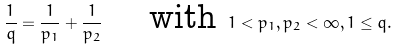Convert formula to latex. <formula><loc_0><loc_0><loc_500><loc_500>\frac { 1 } { q } = \frac { 1 } { p _ { 1 } } + \frac { 1 } { p _ { 2 } } \quad \text { with } 1 < p _ { 1 } , p _ { 2 } < \infty , 1 \leq q .</formula> 